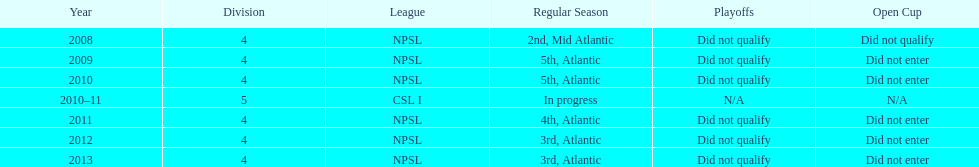What is the final year they managed to rank 3rd? 2013. 